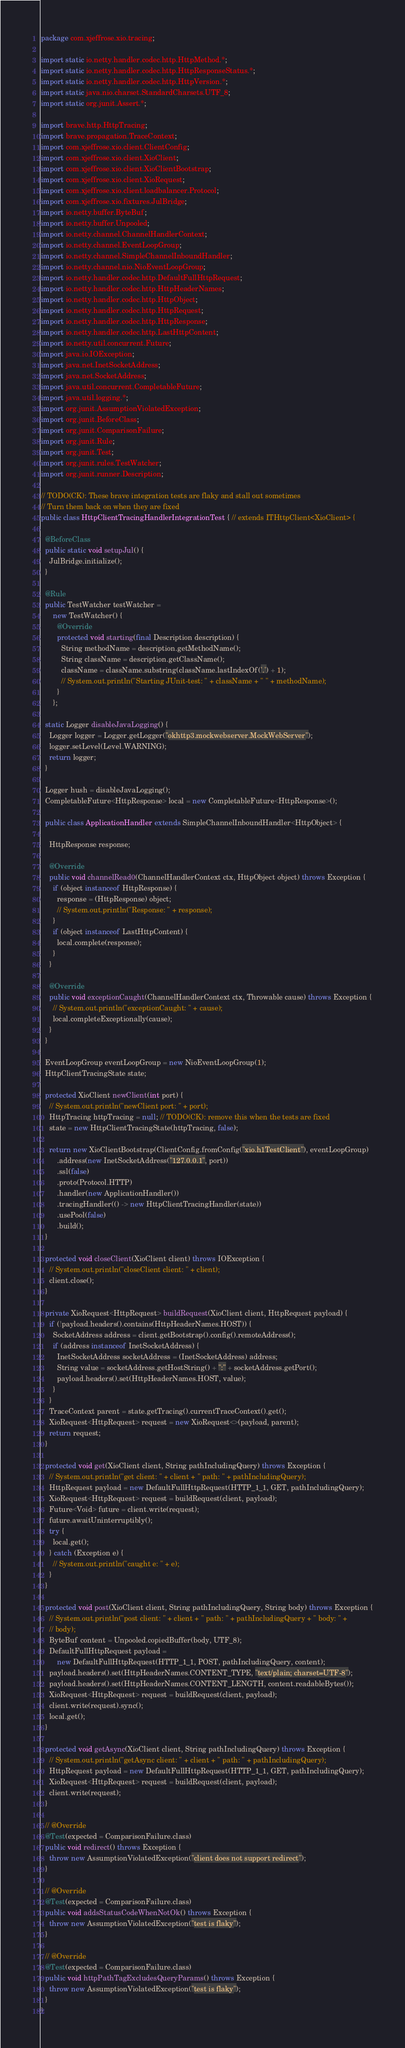<code> <loc_0><loc_0><loc_500><loc_500><_Java_>package com.xjeffrose.xio.tracing;

import static io.netty.handler.codec.http.HttpMethod.*;
import static io.netty.handler.codec.http.HttpResponseStatus.*;
import static io.netty.handler.codec.http.HttpVersion.*;
import static java.nio.charset.StandardCharsets.UTF_8;
import static org.junit.Assert.*;

import brave.http.HttpTracing;
import brave.propagation.TraceContext;
import com.xjeffrose.xio.client.ClientConfig;
import com.xjeffrose.xio.client.XioClient;
import com.xjeffrose.xio.client.XioClientBootstrap;
import com.xjeffrose.xio.client.XioRequest;
import com.xjeffrose.xio.client.loadbalancer.Protocol;
import com.xjeffrose.xio.fixtures.JulBridge;
import io.netty.buffer.ByteBuf;
import io.netty.buffer.Unpooled;
import io.netty.channel.ChannelHandlerContext;
import io.netty.channel.EventLoopGroup;
import io.netty.channel.SimpleChannelInboundHandler;
import io.netty.channel.nio.NioEventLoopGroup;
import io.netty.handler.codec.http.DefaultFullHttpRequest;
import io.netty.handler.codec.http.HttpHeaderNames;
import io.netty.handler.codec.http.HttpObject;
import io.netty.handler.codec.http.HttpRequest;
import io.netty.handler.codec.http.HttpResponse;
import io.netty.handler.codec.http.LastHttpContent;
import io.netty.util.concurrent.Future;
import java.io.IOException;
import java.net.InetSocketAddress;
import java.net.SocketAddress;
import java.util.concurrent.CompletableFuture;
import java.util.logging.*;
import org.junit.AssumptionViolatedException;
import org.junit.BeforeClass;
import org.junit.ComparisonFailure;
import org.junit.Rule;
import org.junit.Test;
import org.junit.rules.TestWatcher;
import org.junit.runner.Description;

// TODO(CK): These brave integration tests are flaky and stall out sometimes
// Turn them back on when they are fixed
public class HttpClientTracingHandlerIntegrationTest { // extends ITHttpClient<XioClient> {

  @BeforeClass
  public static void setupJul() {
    JulBridge.initialize();
  }

  @Rule
  public TestWatcher testWatcher =
      new TestWatcher() {
        @Override
        protected void starting(final Description description) {
          String methodName = description.getMethodName();
          String className = description.getClassName();
          className = className.substring(className.lastIndexOf('.') + 1);
          // System.out.println("Starting JUnit-test: " + className + " " + methodName);
        }
      };

  static Logger disableJavaLogging() {
    Logger logger = Logger.getLogger("okhttp3.mockwebserver.MockWebServer");
    logger.setLevel(Level.WARNING);
    return logger;
  }

  Logger hush = disableJavaLogging();
  CompletableFuture<HttpResponse> local = new CompletableFuture<HttpResponse>();

  public class ApplicationHandler extends SimpleChannelInboundHandler<HttpObject> {

    HttpResponse response;

    @Override
    public void channelRead0(ChannelHandlerContext ctx, HttpObject object) throws Exception {
      if (object instanceof HttpResponse) {
        response = (HttpResponse) object;
        // System.out.println("Response: " + response);
      }
      if (object instanceof LastHttpContent) {
        local.complete(response);
      }
    }

    @Override
    public void exceptionCaught(ChannelHandlerContext ctx, Throwable cause) throws Exception {
      // System.out.println("exceptionCaught: " + cause);
      local.completeExceptionally(cause);
    }
  }

  EventLoopGroup eventLoopGroup = new NioEventLoopGroup(1);
  HttpClientTracingState state;

  protected XioClient newClient(int port) {
    // System.out.println("newClient port: " + port);
    HttpTracing httpTracing = null; // TODO(CK): remove this when the tests are fixed
    state = new HttpClientTracingState(httpTracing, false);

    return new XioClientBootstrap(ClientConfig.fromConfig("xio.h1TestClient"), eventLoopGroup)
        .address(new InetSocketAddress("127.0.0.1", port))
        .ssl(false)
        .proto(Protocol.HTTP)
        .handler(new ApplicationHandler())
        .tracingHandler(() -> new HttpClientTracingHandler(state))
        .usePool(false)
        .build();
  }

  protected void closeClient(XioClient client) throws IOException {
    // System.out.println("closeClient client: " + client);
    client.close();
  }

  private XioRequest<HttpRequest> buildRequest(XioClient client, HttpRequest payload) {
    if (!payload.headers().contains(HttpHeaderNames.HOST)) {
      SocketAddress address = client.getBootstrap().config().remoteAddress();
      if (address instanceof InetSocketAddress) {
        InetSocketAddress socketAddress = (InetSocketAddress) address;
        String value = socketAddress.getHostString() + ":" + socketAddress.getPort();
        payload.headers().set(HttpHeaderNames.HOST, value);
      }
    }
    TraceContext parent = state.getTracing().currentTraceContext().get();
    XioRequest<HttpRequest> request = new XioRequest<>(payload, parent);
    return request;
  }

  protected void get(XioClient client, String pathIncludingQuery) throws Exception {
    // System.out.println("get client: " + client + " path: " + pathIncludingQuery);
    HttpRequest payload = new DefaultFullHttpRequest(HTTP_1_1, GET, pathIncludingQuery);
    XioRequest<HttpRequest> request = buildRequest(client, payload);
    Future<Void> future = client.write(request);
    future.awaitUninterruptibly();
    try {
      local.get();
    } catch (Exception e) {
      // System.out.println("caught e: " + e);
    }
  }

  protected void post(XioClient client, String pathIncludingQuery, String body) throws Exception {
    // System.out.println("post client: " + client + " path: " + pathIncludingQuery + " body: " +
    // body);
    ByteBuf content = Unpooled.copiedBuffer(body, UTF_8);
    DefaultFullHttpRequest payload =
        new DefaultFullHttpRequest(HTTP_1_1, POST, pathIncludingQuery, content);
    payload.headers().set(HttpHeaderNames.CONTENT_TYPE, "text/plain; charset=UTF-8");
    payload.headers().set(HttpHeaderNames.CONTENT_LENGTH, content.readableBytes());
    XioRequest<HttpRequest> request = buildRequest(client, payload);
    client.write(request).sync();
    local.get();
  }

  protected void getAsync(XioClient client, String pathIncludingQuery) throws Exception {
    // System.out.println("getAsync client: " + client + " path: " + pathIncludingQuery);
    HttpRequest payload = new DefaultFullHttpRequest(HTTP_1_1, GET, pathIncludingQuery);
    XioRequest<HttpRequest> request = buildRequest(client, payload);
    client.write(request);
  }

  // @Override
  @Test(expected = ComparisonFailure.class)
  public void redirect() throws Exception {
    throw new AssumptionViolatedException("client does not support redirect");
  }

  // @Override
  @Test(expected = ComparisonFailure.class)
  public void addsStatusCodeWhenNotOk() throws Exception {
    throw new AssumptionViolatedException("test is flaky");
  }

  // @Override
  @Test(expected = ComparisonFailure.class)
  public void httpPathTagExcludesQueryParams() throws Exception {
    throw new AssumptionViolatedException("test is flaky");
  }
}
</code> 